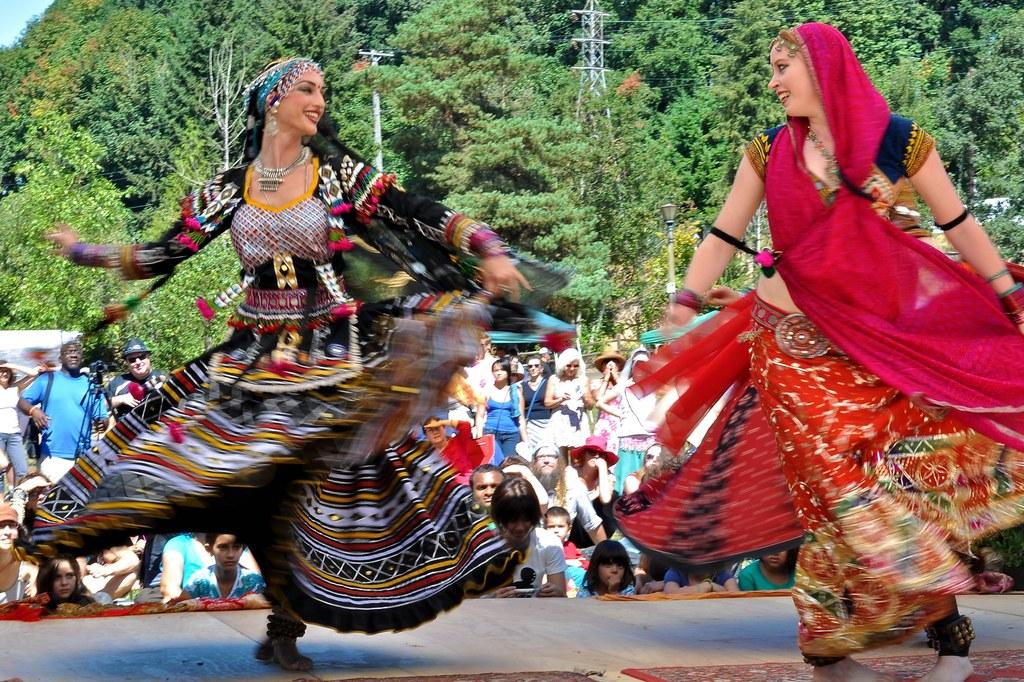What are the women in the center of the image doing? The women are standing and performing in the center of the image. Where are the women performing? The women are on a dais. What can be seen in the background of the image? There is a crowd, a tower, a pole, and trees in the background of the image. What type of butter is being used by the women in the image? There is no butter present in the image; the women are performing. What color is the ink used by the women in the image? There is no ink present in the image; the women are performing without any visible writing materials. 